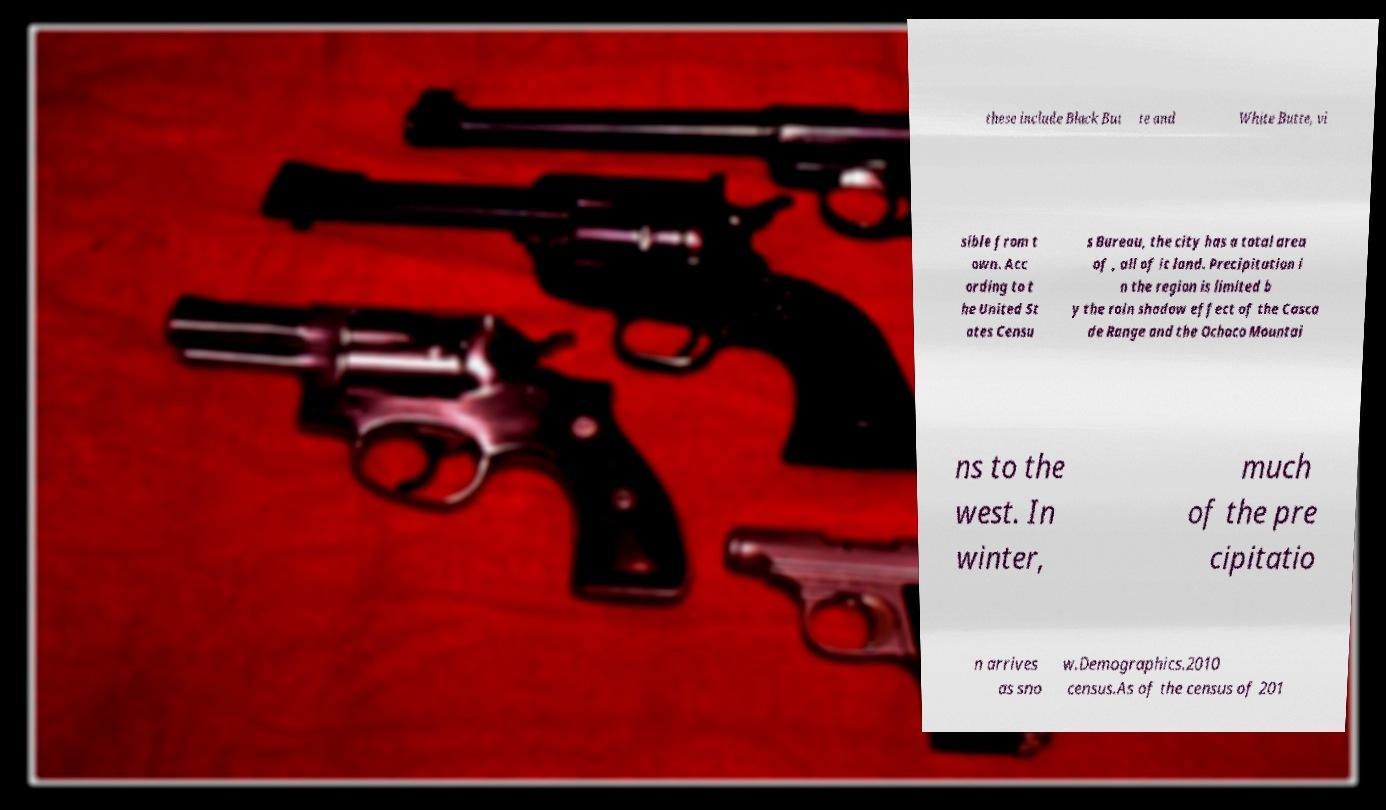Could you extract and type out the text from this image? these include Black But te and White Butte, vi sible from t own. Acc ording to t he United St ates Censu s Bureau, the city has a total area of , all of it land. Precipitation i n the region is limited b y the rain shadow effect of the Casca de Range and the Ochoco Mountai ns to the west. In winter, much of the pre cipitatio n arrives as sno w.Demographics.2010 census.As of the census of 201 